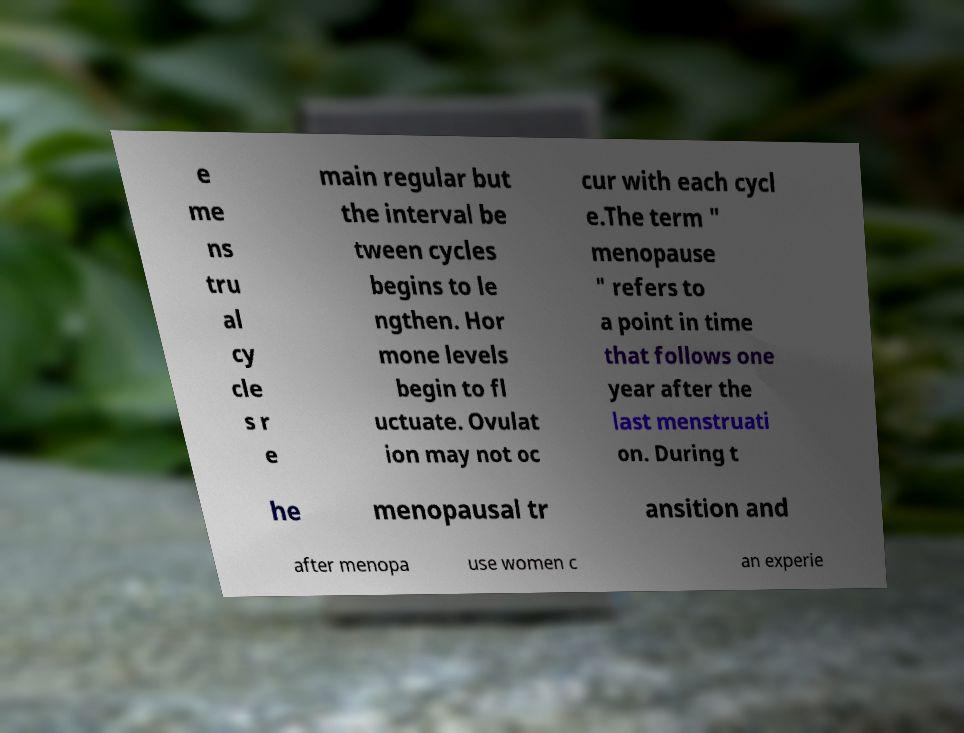Please read and relay the text visible in this image. What does it say? e me ns tru al cy cle s r e main regular but the interval be tween cycles begins to le ngthen. Hor mone levels begin to fl uctuate. Ovulat ion may not oc cur with each cycl e.The term " menopause " refers to a point in time that follows one year after the last menstruati on. During t he menopausal tr ansition and after menopa use women c an experie 